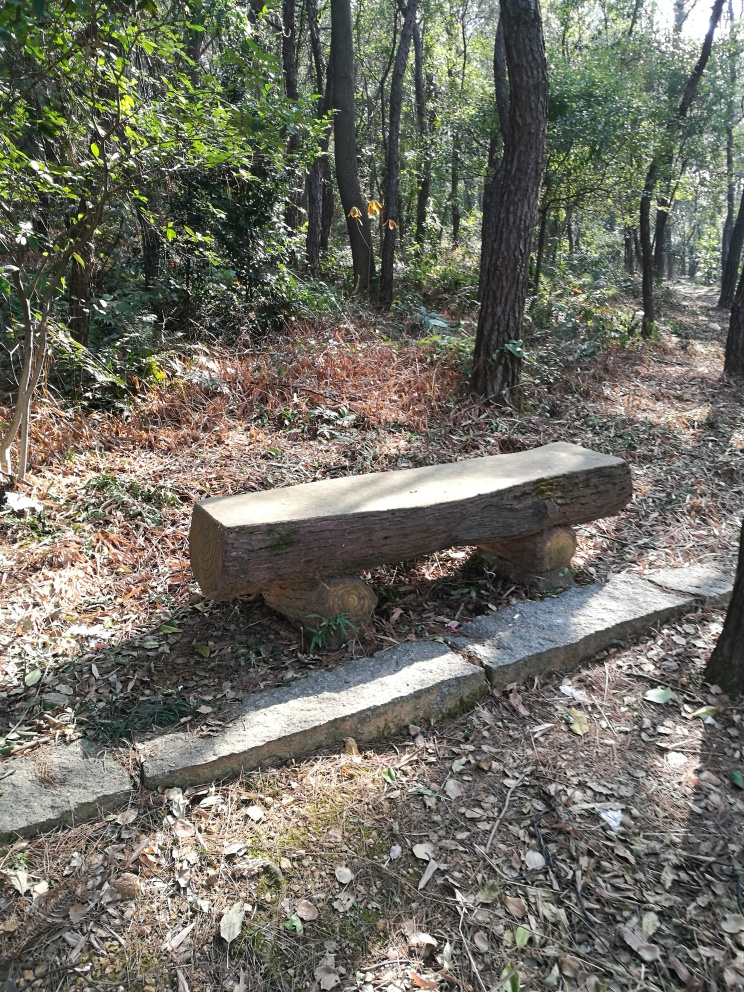Are there any overexposed areas in the image? Upon reviewing the image, it appears that there are no significantly overexposed areas where details are lost to white. The sunlight creates bright spots, especially on the forest floor and along the edges of the wooden bench, but the integrity of the image is maintained with details still visible throughout. 